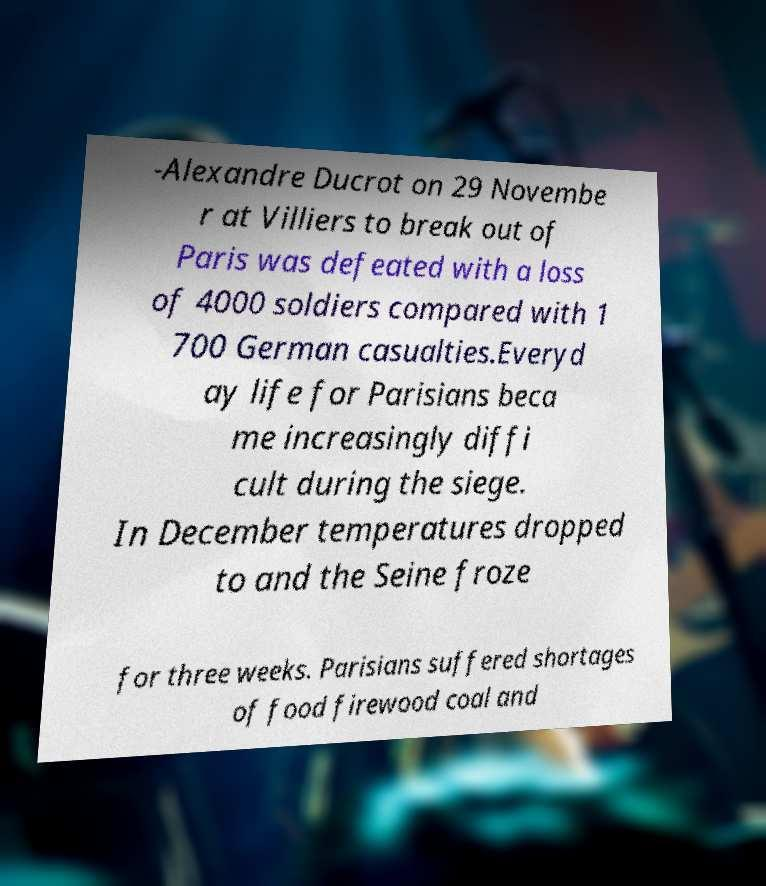Please read and relay the text visible in this image. What does it say? -Alexandre Ducrot on 29 Novembe r at Villiers to break out of Paris was defeated with a loss of 4000 soldiers compared with 1 700 German casualties.Everyd ay life for Parisians beca me increasingly diffi cult during the siege. In December temperatures dropped to and the Seine froze for three weeks. Parisians suffered shortages of food firewood coal and 